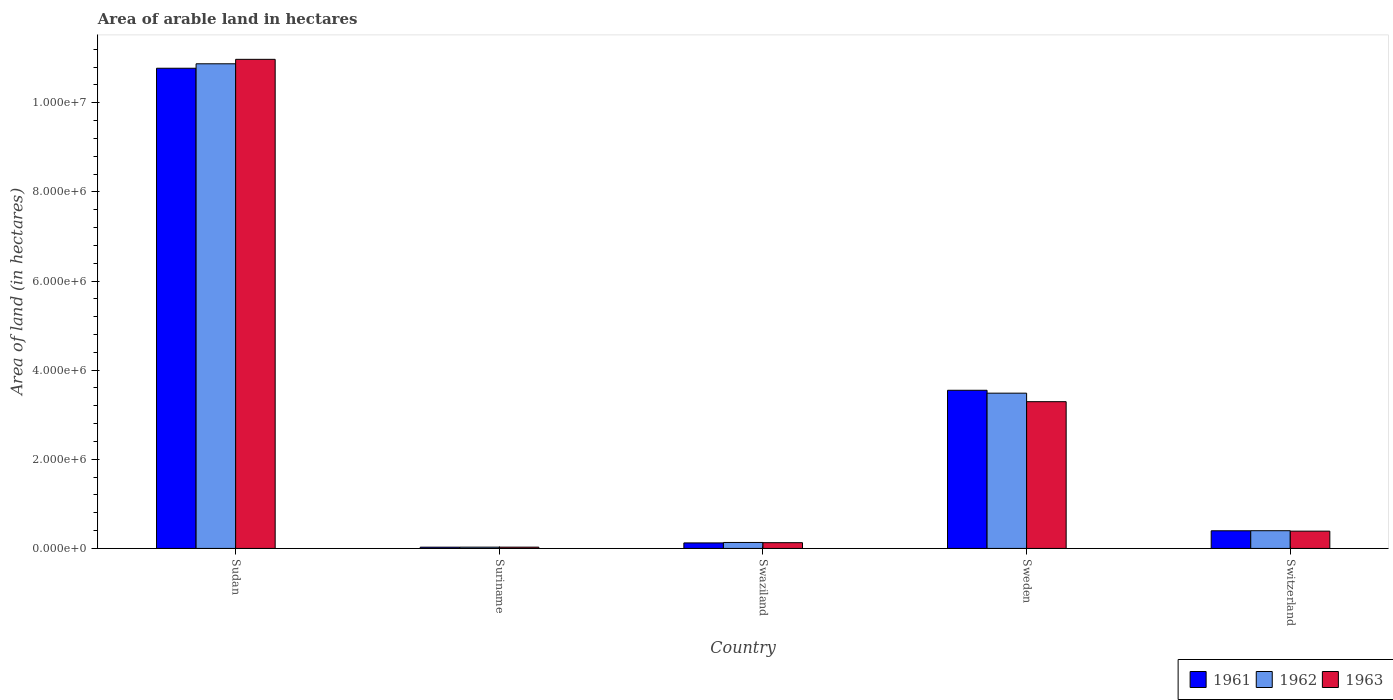How many different coloured bars are there?
Your answer should be very brief. 3. How many groups of bars are there?
Provide a succinct answer. 5. Are the number of bars per tick equal to the number of legend labels?
Keep it short and to the point. Yes. Are the number of bars on each tick of the X-axis equal?
Offer a terse response. Yes. How many bars are there on the 2nd tick from the left?
Offer a terse response. 3. How many bars are there on the 2nd tick from the right?
Provide a short and direct response. 3. What is the label of the 3rd group of bars from the left?
Make the answer very short. Swaziland. In how many cases, is the number of bars for a given country not equal to the number of legend labels?
Offer a terse response. 0. What is the total arable land in 1961 in Sweden?
Offer a very short reply. 3.55e+06. Across all countries, what is the maximum total arable land in 1961?
Offer a terse response. 1.08e+07. Across all countries, what is the minimum total arable land in 1962?
Keep it short and to the point. 2.90e+04. In which country was the total arable land in 1961 maximum?
Keep it short and to the point. Sudan. In which country was the total arable land in 1963 minimum?
Provide a short and direct response. Suriname. What is the total total arable land in 1962 in the graph?
Make the answer very short. 1.49e+07. What is the difference between the total arable land in 1962 in Sudan and that in Swaziland?
Provide a succinct answer. 1.07e+07. What is the difference between the total arable land in 1962 in Switzerland and the total arable land in 1961 in Swaziland?
Offer a terse response. 2.74e+05. What is the average total arable land in 1961 per country?
Ensure brevity in your answer.  2.97e+06. What is the difference between the total arable land of/in 1962 and total arable land of/in 1963 in Sudan?
Provide a succinct answer. -1.00e+05. In how many countries, is the total arable land in 1963 greater than 2400000 hectares?
Make the answer very short. 2. What is the ratio of the total arable land in 1961 in Swaziland to that in Switzerland?
Give a very brief answer. 0.31. What is the difference between the highest and the second highest total arable land in 1962?
Offer a terse response. 1.05e+07. What is the difference between the highest and the lowest total arable land in 1962?
Your answer should be compact. 1.08e+07. Is the sum of the total arable land in 1962 in Swaziland and Switzerland greater than the maximum total arable land in 1963 across all countries?
Give a very brief answer. No. What does the 2nd bar from the right in Switzerland represents?
Make the answer very short. 1962. What is the difference between two consecutive major ticks on the Y-axis?
Offer a terse response. 2.00e+06. Does the graph contain grids?
Your answer should be compact. No. Where does the legend appear in the graph?
Provide a short and direct response. Bottom right. What is the title of the graph?
Provide a short and direct response. Area of arable land in hectares. Does "1989" appear as one of the legend labels in the graph?
Your answer should be very brief. No. What is the label or title of the Y-axis?
Offer a terse response. Area of land (in hectares). What is the Area of land (in hectares) of 1961 in Sudan?
Provide a succinct answer. 1.08e+07. What is the Area of land (in hectares) of 1962 in Sudan?
Your answer should be very brief. 1.09e+07. What is the Area of land (in hectares) of 1963 in Sudan?
Give a very brief answer. 1.10e+07. What is the Area of land (in hectares) in 1961 in Suriname?
Your answer should be very brief. 2.80e+04. What is the Area of land (in hectares) of 1962 in Suriname?
Offer a very short reply. 2.90e+04. What is the Area of land (in hectares) of 1963 in Suriname?
Give a very brief answer. 2.90e+04. What is the Area of land (in hectares) of 1961 in Swaziland?
Give a very brief answer. 1.24e+05. What is the Area of land (in hectares) of 1962 in Swaziland?
Your answer should be compact. 1.34e+05. What is the Area of land (in hectares) in 1963 in Swaziland?
Keep it short and to the point. 1.29e+05. What is the Area of land (in hectares) in 1961 in Sweden?
Provide a succinct answer. 3.55e+06. What is the Area of land (in hectares) in 1962 in Sweden?
Ensure brevity in your answer.  3.48e+06. What is the Area of land (in hectares) in 1963 in Sweden?
Your answer should be very brief. 3.29e+06. What is the Area of land (in hectares) of 1961 in Switzerland?
Make the answer very short. 3.96e+05. What is the Area of land (in hectares) in 1962 in Switzerland?
Your answer should be very brief. 3.98e+05. What is the Area of land (in hectares) of 1963 in Switzerland?
Your answer should be compact. 3.88e+05. Across all countries, what is the maximum Area of land (in hectares) in 1961?
Offer a very short reply. 1.08e+07. Across all countries, what is the maximum Area of land (in hectares) of 1962?
Offer a terse response. 1.09e+07. Across all countries, what is the maximum Area of land (in hectares) of 1963?
Provide a succinct answer. 1.10e+07. Across all countries, what is the minimum Area of land (in hectares) in 1961?
Offer a terse response. 2.80e+04. Across all countries, what is the minimum Area of land (in hectares) in 1962?
Give a very brief answer. 2.90e+04. Across all countries, what is the minimum Area of land (in hectares) of 1963?
Your answer should be compact. 2.90e+04. What is the total Area of land (in hectares) in 1961 in the graph?
Keep it short and to the point. 1.49e+07. What is the total Area of land (in hectares) in 1962 in the graph?
Your response must be concise. 1.49e+07. What is the total Area of land (in hectares) in 1963 in the graph?
Offer a very short reply. 1.48e+07. What is the difference between the Area of land (in hectares) of 1961 in Sudan and that in Suriname?
Your answer should be very brief. 1.07e+07. What is the difference between the Area of land (in hectares) in 1962 in Sudan and that in Suriname?
Offer a terse response. 1.08e+07. What is the difference between the Area of land (in hectares) of 1963 in Sudan and that in Suriname?
Provide a short and direct response. 1.09e+07. What is the difference between the Area of land (in hectares) in 1961 in Sudan and that in Swaziland?
Your response must be concise. 1.07e+07. What is the difference between the Area of land (in hectares) in 1962 in Sudan and that in Swaziland?
Offer a very short reply. 1.07e+07. What is the difference between the Area of land (in hectares) of 1963 in Sudan and that in Swaziland?
Provide a short and direct response. 1.08e+07. What is the difference between the Area of land (in hectares) of 1961 in Sudan and that in Sweden?
Your response must be concise. 7.23e+06. What is the difference between the Area of land (in hectares) in 1962 in Sudan and that in Sweden?
Ensure brevity in your answer.  7.39e+06. What is the difference between the Area of land (in hectares) of 1963 in Sudan and that in Sweden?
Keep it short and to the point. 7.68e+06. What is the difference between the Area of land (in hectares) of 1961 in Sudan and that in Switzerland?
Provide a succinct answer. 1.04e+07. What is the difference between the Area of land (in hectares) of 1962 in Sudan and that in Switzerland?
Your response must be concise. 1.05e+07. What is the difference between the Area of land (in hectares) in 1963 in Sudan and that in Switzerland?
Your response must be concise. 1.06e+07. What is the difference between the Area of land (in hectares) of 1961 in Suriname and that in Swaziland?
Give a very brief answer. -9.60e+04. What is the difference between the Area of land (in hectares) in 1962 in Suriname and that in Swaziland?
Keep it short and to the point. -1.05e+05. What is the difference between the Area of land (in hectares) of 1961 in Suriname and that in Sweden?
Give a very brief answer. -3.52e+06. What is the difference between the Area of land (in hectares) of 1962 in Suriname and that in Sweden?
Your response must be concise. -3.46e+06. What is the difference between the Area of land (in hectares) in 1963 in Suriname and that in Sweden?
Ensure brevity in your answer.  -3.26e+06. What is the difference between the Area of land (in hectares) in 1961 in Suriname and that in Switzerland?
Your response must be concise. -3.68e+05. What is the difference between the Area of land (in hectares) of 1962 in Suriname and that in Switzerland?
Provide a succinct answer. -3.69e+05. What is the difference between the Area of land (in hectares) in 1963 in Suriname and that in Switzerland?
Your response must be concise. -3.59e+05. What is the difference between the Area of land (in hectares) of 1961 in Swaziland and that in Sweden?
Your answer should be very brief. -3.42e+06. What is the difference between the Area of land (in hectares) of 1962 in Swaziland and that in Sweden?
Offer a very short reply. -3.35e+06. What is the difference between the Area of land (in hectares) in 1963 in Swaziland and that in Sweden?
Your response must be concise. -3.16e+06. What is the difference between the Area of land (in hectares) of 1961 in Swaziland and that in Switzerland?
Offer a terse response. -2.72e+05. What is the difference between the Area of land (in hectares) in 1962 in Swaziland and that in Switzerland?
Offer a terse response. -2.64e+05. What is the difference between the Area of land (in hectares) of 1963 in Swaziland and that in Switzerland?
Your answer should be very brief. -2.59e+05. What is the difference between the Area of land (in hectares) in 1961 in Sweden and that in Switzerland?
Make the answer very short. 3.15e+06. What is the difference between the Area of land (in hectares) in 1962 in Sweden and that in Switzerland?
Provide a short and direct response. 3.09e+06. What is the difference between the Area of land (in hectares) in 1963 in Sweden and that in Switzerland?
Keep it short and to the point. 2.91e+06. What is the difference between the Area of land (in hectares) of 1961 in Sudan and the Area of land (in hectares) of 1962 in Suriname?
Keep it short and to the point. 1.07e+07. What is the difference between the Area of land (in hectares) in 1961 in Sudan and the Area of land (in hectares) in 1963 in Suriname?
Your response must be concise. 1.07e+07. What is the difference between the Area of land (in hectares) of 1962 in Sudan and the Area of land (in hectares) of 1963 in Suriname?
Make the answer very short. 1.08e+07. What is the difference between the Area of land (in hectares) in 1961 in Sudan and the Area of land (in hectares) in 1962 in Swaziland?
Ensure brevity in your answer.  1.06e+07. What is the difference between the Area of land (in hectares) in 1961 in Sudan and the Area of land (in hectares) in 1963 in Swaziland?
Keep it short and to the point. 1.06e+07. What is the difference between the Area of land (in hectares) in 1962 in Sudan and the Area of land (in hectares) in 1963 in Swaziland?
Provide a succinct answer. 1.07e+07. What is the difference between the Area of land (in hectares) of 1961 in Sudan and the Area of land (in hectares) of 1962 in Sweden?
Ensure brevity in your answer.  7.29e+06. What is the difference between the Area of land (in hectares) in 1961 in Sudan and the Area of land (in hectares) in 1963 in Sweden?
Provide a succinct answer. 7.48e+06. What is the difference between the Area of land (in hectares) in 1962 in Sudan and the Area of land (in hectares) in 1963 in Sweden?
Your response must be concise. 7.58e+06. What is the difference between the Area of land (in hectares) of 1961 in Sudan and the Area of land (in hectares) of 1962 in Switzerland?
Ensure brevity in your answer.  1.04e+07. What is the difference between the Area of land (in hectares) of 1961 in Sudan and the Area of land (in hectares) of 1963 in Switzerland?
Offer a very short reply. 1.04e+07. What is the difference between the Area of land (in hectares) in 1962 in Sudan and the Area of land (in hectares) in 1963 in Switzerland?
Your answer should be compact. 1.05e+07. What is the difference between the Area of land (in hectares) of 1961 in Suriname and the Area of land (in hectares) of 1962 in Swaziland?
Keep it short and to the point. -1.06e+05. What is the difference between the Area of land (in hectares) of 1961 in Suriname and the Area of land (in hectares) of 1963 in Swaziland?
Give a very brief answer. -1.01e+05. What is the difference between the Area of land (in hectares) of 1962 in Suriname and the Area of land (in hectares) of 1963 in Swaziland?
Offer a terse response. -1.00e+05. What is the difference between the Area of land (in hectares) in 1961 in Suriname and the Area of land (in hectares) in 1962 in Sweden?
Provide a short and direct response. -3.46e+06. What is the difference between the Area of land (in hectares) of 1961 in Suriname and the Area of land (in hectares) of 1963 in Sweden?
Your answer should be very brief. -3.26e+06. What is the difference between the Area of land (in hectares) of 1962 in Suriname and the Area of land (in hectares) of 1963 in Sweden?
Provide a short and direct response. -3.26e+06. What is the difference between the Area of land (in hectares) of 1961 in Suriname and the Area of land (in hectares) of 1962 in Switzerland?
Provide a succinct answer. -3.70e+05. What is the difference between the Area of land (in hectares) in 1961 in Suriname and the Area of land (in hectares) in 1963 in Switzerland?
Offer a very short reply. -3.60e+05. What is the difference between the Area of land (in hectares) of 1962 in Suriname and the Area of land (in hectares) of 1963 in Switzerland?
Offer a terse response. -3.59e+05. What is the difference between the Area of land (in hectares) in 1961 in Swaziland and the Area of land (in hectares) in 1962 in Sweden?
Ensure brevity in your answer.  -3.36e+06. What is the difference between the Area of land (in hectares) of 1961 in Swaziland and the Area of land (in hectares) of 1963 in Sweden?
Provide a short and direct response. -3.17e+06. What is the difference between the Area of land (in hectares) of 1962 in Swaziland and the Area of land (in hectares) of 1963 in Sweden?
Ensure brevity in your answer.  -3.16e+06. What is the difference between the Area of land (in hectares) in 1961 in Swaziland and the Area of land (in hectares) in 1962 in Switzerland?
Offer a very short reply. -2.74e+05. What is the difference between the Area of land (in hectares) in 1961 in Swaziland and the Area of land (in hectares) in 1963 in Switzerland?
Your answer should be compact. -2.64e+05. What is the difference between the Area of land (in hectares) of 1962 in Swaziland and the Area of land (in hectares) of 1963 in Switzerland?
Keep it short and to the point. -2.54e+05. What is the difference between the Area of land (in hectares) in 1961 in Sweden and the Area of land (in hectares) in 1962 in Switzerland?
Keep it short and to the point. 3.15e+06. What is the difference between the Area of land (in hectares) of 1961 in Sweden and the Area of land (in hectares) of 1963 in Switzerland?
Your answer should be compact. 3.16e+06. What is the difference between the Area of land (in hectares) in 1962 in Sweden and the Area of land (in hectares) in 1963 in Switzerland?
Give a very brief answer. 3.10e+06. What is the average Area of land (in hectares) in 1961 per country?
Make the answer very short. 2.97e+06. What is the average Area of land (in hectares) of 1962 per country?
Provide a short and direct response. 2.98e+06. What is the average Area of land (in hectares) in 1963 per country?
Provide a succinct answer. 2.96e+06. What is the difference between the Area of land (in hectares) of 1961 and Area of land (in hectares) of 1963 in Sudan?
Provide a succinct answer. -2.00e+05. What is the difference between the Area of land (in hectares) of 1961 and Area of land (in hectares) of 1962 in Suriname?
Ensure brevity in your answer.  -1000. What is the difference between the Area of land (in hectares) in 1961 and Area of land (in hectares) in 1963 in Suriname?
Give a very brief answer. -1000. What is the difference between the Area of land (in hectares) of 1961 and Area of land (in hectares) of 1963 in Swaziland?
Your response must be concise. -5000. What is the difference between the Area of land (in hectares) in 1962 and Area of land (in hectares) in 1963 in Swaziland?
Offer a very short reply. 5000. What is the difference between the Area of land (in hectares) of 1961 and Area of land (in hectares) of 1962 in Sweden?
Ensure brevity in your answer.  6.50e+04. What is the difference between the Area of land (in hectares) in 1961 and Area of land (in hectares) in 1963 in Sweden?
Your response must be concise. 2.56e+05. What is the difference between the Area of land (in hectares) of 1962 and Area of land (in hectares) of 1963 in Sweden?
Your answer should be compact. 1.91e+05. What is the difference between the Area of land (in hectares) of 1961 and Area of land (in hectares) of 1962 in Switzerland?
Provide a short and direct response. -1600. What is the difference between the Area of land (in hectares) of 1961 and Area of land (in hectares) of 1963 in Switzerland?
Offer a very short reply. 8200. What is the difference between the Area of land (in hectares) in 1962 and Area of land (in hectares) in 1963 in Switzerland?
Make the answer very short. 9800. What is the ratio of the Area of land (in hectares) of 1961 in Sudan to that in Suriname?
Keep it short and to the point. 384.82. What is the ratio of the Area of land (in hectares) of 1962 in Sudan to that in Suriname?
Provide a short and direct response. 375. What is the ratio of the Area of land (in hectares) in 1963 in Sudan to that in Suriname?
Offer a terse response. 378.45. What is the ratio of the Area of land (in hectares) in 1961 in Sudan to that in Swaziland?
Keep it short and to the point. 86.9. What is the ratio of the Area of land (in hectares) of 1962 in Sudan to that in Swaziland?
Offer a terse response. 81.16. What is the ratio of the Area of land (in hectares) in 1963 in Sudan to that in Swaziland?
Your answer should be compact. 85.08. What is the ratio of the Area of land (in hectares) in 1961 in Sudan to that in Sweden?
Your response must be concise. 3.04. What is the ratio of the Area of land (in hectares) in 1962 in Sudan to that in Sweden?
Give a very brief answer. 3.12. What is the ratio of the Area of land (in hectares) in 1963 in Sudan to that in Sweden?
Your answer should be very brief. 3.33. What is the ratio of the Area of land (in hectares) in 1961 in Sudan to that in Switzerland?
Provide a short and direct response. 27.2. What is the ratio of the Area of land (in hectares) in 1962 in Sudan to that in Switzerland?
Offer a very short reply. 27.34. What is the ratio of the Area of land (in hectares) of 1963 in Sudan to that in Switzerland?
Keep it short and to the point. 28.29. What is the ratio of the Area of land (in hectares) of 1961 in Suriname to that in Swaziland?
Keep it short and to the point. 0.23. What is the ratio of the Area of land (in hectares) in 1962 in Suriname to that in Swaziland?
Your answer should be very brief. 0.22. What is the ratio of the Area of land (in hectares) of 1963 in Suriname to that in Swaziland?
Your response must be concise. 0.22. What is the ratio of the Area of land (in hectares) in 1961 in Suriname to that in Sweden?
Your response must be concise. 0.01. What is the ratio of the Area of land (in hectares) in 1962 in Suriname to that in Sweden?
Provide a short and direct response. 0.01. What is the ratio of the Area of land (in hectares) of 1963 in Suriname to that in Sweden?
Offer a very short reply. 0.01. What is the ratio of the Area of land (in hectares) in 1961 in Suriname to that in Switzerland?
Offer a terse response. 0.07. What is the ratio of the Area of land (in hectares) of 1962 in Suriname to that in Switzerland?
Provide a short and direct response. 0.07. What is the ratio of the Area of land (in hectares) of 1963 in Suriname to that in Switzerland?
Offer a very short reply. 0.07. What is the ratio of the Area of land (in hectares) in 1961 in Swaziland to that in Sweden?
Ensure brevity in your answer.  0.03. What is the ratio of the Area of land (in hectares) of 1962 in Swaziland to that in Sweden?
Your answer should be compact. 0.04. What is the ratio of the Area of land (in hectares) of 1963 in Swaziland to that in Sweden?
Provide a succinct answer. 0.04. What is the ratio of the Area of land (in hectares) in 1961 in Swaziland to that in Switzerland?
Provide a short and direct response. 0.31. What is the ratio of the Area of land (in hectares) of 1962 in Swaziland to that in Switzerland?
Provide a succinct answer. 0.34. What is the ratio of the Area of land (in hectares) in 1963 in Swaziland to that in Switzerland?
Provide a short and direct response. 0.33. What is the ratio of the Area of land (in hectares) in 1961 in Sweden to that in Switzerland?
Offer a terse response. 8.96. What is the ratio of the Area of land (in hectares) in 1962 in Sweden to that in Switzerland?
Your answer should be very brief. 8.76. What is the ratio of the Area of land (in hectares) of 1963 in Sweden to that in Switzerland?
Ensure brevity in your answer.  8.49. What is the difference between the highest and the second highest Area of land (in hectares) in 1961?
Keep it short and to the point. 7.23e+06. What is the difference between the highest and the second highest Area of land (in hectares) in 1962?
Offer a terse response. 7.39e+06. What is the difference between the highest and the second highest Area of land (in hectares) in 1963?
Give a very brief answer. 7.68e+06. What is the difference between the highest and the lowest Area of land (in hectares) in 1961?
Your answer should be compact. 1.07e+07. What is the difference between the highest and the lowest Area of land (in hectares) of 1962?
Keep it short and to the point. 1.08e+07. What is the difference between the highest and the lowest Area of land (in hectares) of 1963?
Give a very brief answer. 1.09e+07. 